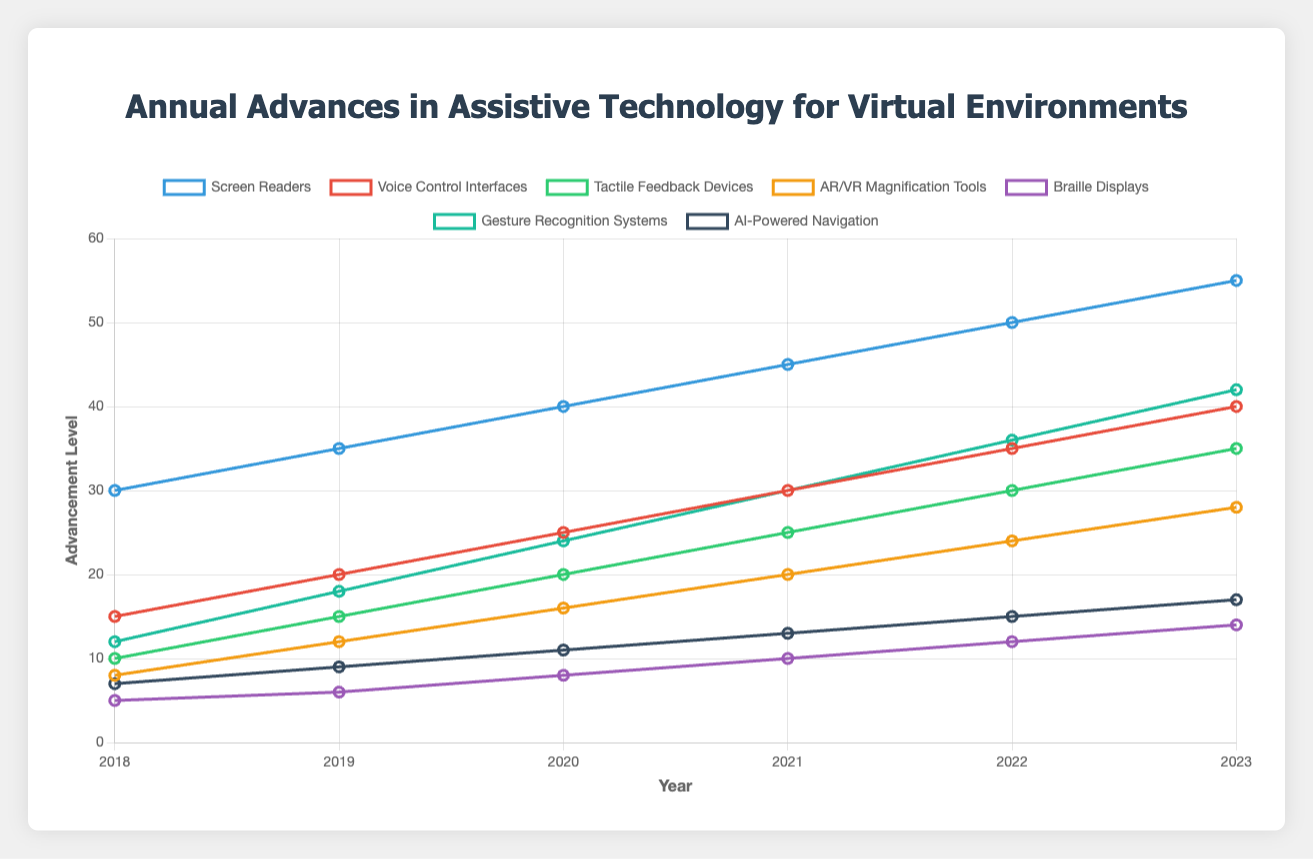What is the trend for Screen Readers from 2018 to 2023? The trend for Screen Readers shows a steady increase each year. Starting from 30 in 2018, it goes up by 5 units each year, reaching 55 in 2023.
Answer: Steady increase Which technology had the highest advancement level in 2023? Gesture Recognition Systems had the highest advancement level in 2023, with a value of 42.
Answer: Gesture Recognition Systems What is the difference in advancement levels between Voice Control Interfaces and AI-Powered Navigation in 2023? In 2023, Voice Control Interfaces have a value of 40, and AI-Powered Navigation has a value of 17. The difference is 40 - 17, which equals 23.
Answer: 23 Which technology showed the most significant increase from 2018 to 2023? Gesture Recognition Systems showed the most significant increase, starting from 12 in 2018 and reaching 42 in 2023, making an overall increase of 30.
Answer: Gesture Recognition Systems What is the average advancement level of Tactile Feedback Devices over the years provided? The values for Tactile Feedback Devices are 10, 15, 20, 25, 30, and 35. Summing these up gives 135, and there are 6 years. So, the average is 135 / 6 = 22.5.
Answer: 22.5 Compare the advancement levels of Screen Readers and Braille Displays in 2021. Which one is higher, and by how much? In 2021, Screen Readers have an advancement level of 45, while Braille Displays have 10. Screen Readers are higher by 45 - 10 = 35.
Answer: Screen Readers, by 35 How much did AR/VR Magnification Tools advance between 2018 and 2020? In 2018, AR/VR Magnification Tools had a value of 8. By 2020, it was 16. Therefore, the advancement from 2018 to 2020 is 16 - 8 = 8.
Answer: 8 Which two technologies had equal advancement levels in any year? In 2020, Tactile Feedback Devices and Voice Control Interfaces both had an advancement level of 25.
Answer: Tactile Feedback Devices and Voice Control Interfaces, in 2020 What is the total increase in advancement level for Braille Displays from 2018 to 2023? The values for Braille Displays are 5, 6, 8, 10, 12, and 14. The increase from 2018 to 2023 is 14 - 5 = 9.
Answer: 9 What color represents AI-Powered Navigation on the chart? AI-Powered Navigation is represented by a dark blue line.
Answer: Dark blue 